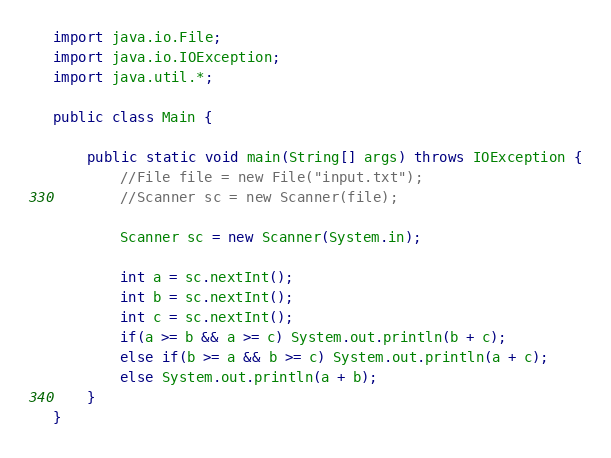<code> <loc_0><loc_0><loc_500><loc_500><_Java_>import java.io.File;
import java.io.IOException;
import java.util.*;
 
public class Main {
 
	public static void main(String[] args) throws IOException {
		//File file = new File("input.txt");
		//Scanner sc = new Scanner(file);
		
		Scanner sc = new Scanner(System.in);
		
		int a = sc.nextInt();
		int b = sc.nextInt();
		int c = sc.nextInt();
		if(a >= b && a >= c) System.out.println(b + c);
		else if(b >= a && b >= c) System.out.println(a + c);
		else System.out.println(a + b);
	}
}</code> 